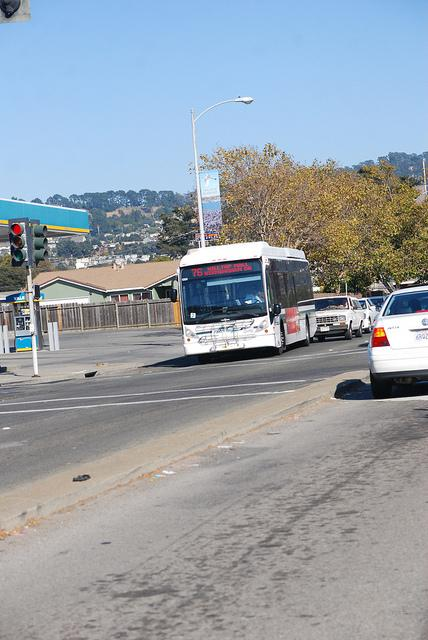Which vehicle is leading the ones on the left side?

Choices:
A) airplane
B) tank
C) bus
D) motorcycle bus 